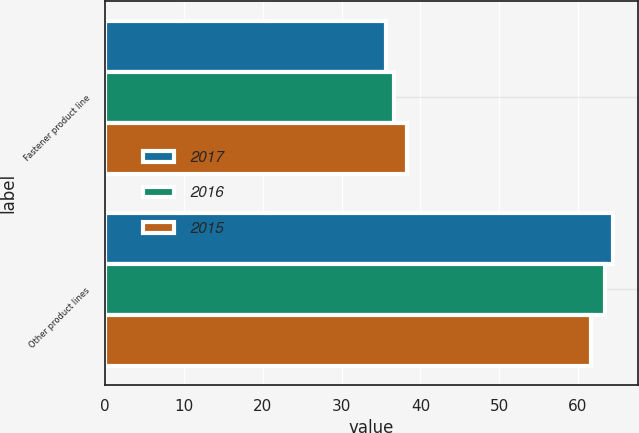Convert chart. <chart><loc_0><loc_0><loc_500><loc_500><stacked_bar_chart><ecel><fcel>Fastener product line<fcel>Other product lines<nl><fcel>2017<fcel>35.6<fcel>64.4<nl><fcel>2016<fcel>36.6<fcel>63.4<nl><fcel>2015<fcel>38.3<fcel>61.7<nl></chart> 